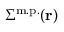<formula> <loc_0><loc_0><loc_500><loc_500>\Sigma ^ { m . p . } ( r )</formula> 